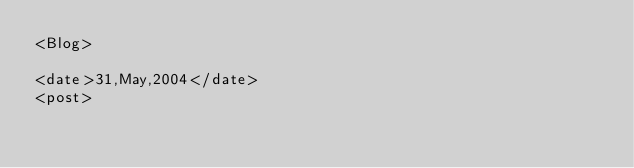<code> <loc_0><loc_0><loc_500><loc_500><_XML_><Blog>

<date>31,May,2004</date>
<post>

     </code> 